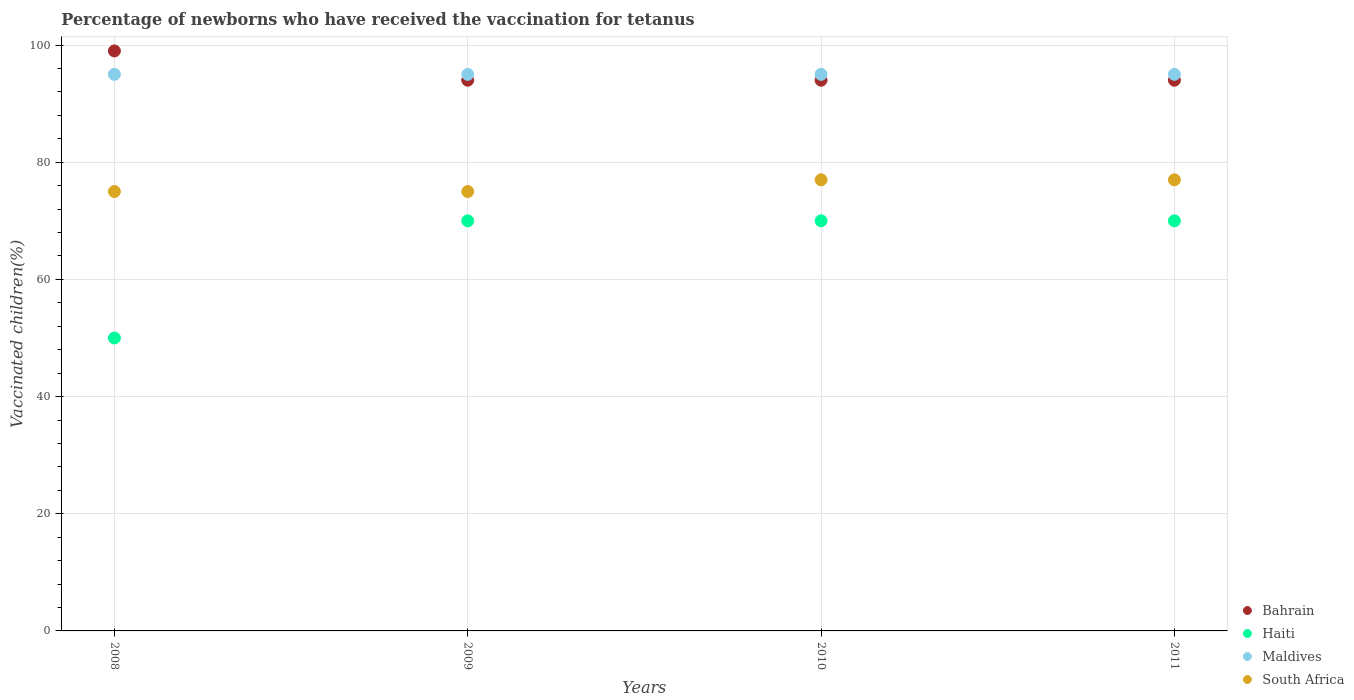How many different coloured dotlines are there?
Your answer should be compact. 4. What is the percentage of vaccinated children in Bahrain in 2008?
Offer a terse response. 99. Across all years, what is the maximum percentage of vaccinated children in Bahrain?
Give a very brief answer. 99. Across all years, what is the minimum percentage of vaccinated children in Bahrain?
Offer a very short reply. 94. In which year was the percentage of vaccinated children in Bahrain maximum?
Give a very brief answer. 2008. In which year was the percentage of vaccinated children in Maldives minimum?
Provide a succinct answer. 2008. What is the total percentage of vaccinated children in Haiti in the graph?
Provide a short and direct response. 260. What is the difference between the percentage of vaccinated children in Bahrain in 2008 and that in 2011?
Your response must be concise. 5. What is the difference between the percentage of vaccinated children in Haiti in 2010 and the percentage of vaccinated children in Maldives in 2009?
Keep it short and to the point. -25. What is the average percentage of vaccinated children in South Africa per year?
Provide a succinct answer. 76. In the year 2010, what is the difference between the percentage of vaccinated children in South Africa and percentage of vaccinated children in Maldives?
Ensure brevity in your answer.  -18. What is the ratio of the percentage of vaccinated children in Haiti in 2009 to that in 2011?
Offer a terse response. 1. Is the percentage of vaccinated children in Bahrain in 2008 less than that in 2011?
Your answer should be compact. No. What is the difference between the highest and the lowest percentage of vaccinated children in Maldives?
Your answer should be compact. 0. In how many years, is the percentage of vaccinated children in South Africa greater than the average percentage of vaccinated children in South Africa taken over all years?
Ensure brevity in your answer.  2. Is the percentage of vaccinated children in Maldives strictly less than the percentage of vaccinated children in Haiti over the years?
Your answer should be compact. No. How many dotlines are there?
Provide a short and direct response. 4. How many years are there in the graph?
Offer a very short reply. 4. Are the values on the major ticks of Y-axis written in scientific E-notation?
Keep it short and to the point. No. Does the graph contain any zero values?
Provide a succinct answer. No. How many legend labels are there?
Your answer should be compact. 4. How are the legend labels stacked?
Ensure brevity in your answer.  Vertical. What is the title of the graph?
Your response must be concise. Percentage of newborns who have received the vaccination for tetanus. What is the label or title of the X-axis?
Your answer should be compact. Years. What is the label or title of the Y-axis?
Your response must be concise. Vaccinated children(%). What is the Vaccinated children(%) in Bahrain in 2008?
Give a very brief answer. 99. What is the Vaccinated children(%) in South Africa in 2008?
Offer a very short reply. 75. What is the Vaccinated children(%) in Bahrain in 2009?
Provide a succinct answer. 94. What is the Vaccinated children(%) of Maldives in 2009?
Your answer should be very brief. 95. What is the Vaccinated children(%) in Bahrain in 2010?
Make the answer very short. 94. What is the Vaccinated children(%) in Haiti in 2010?
Provide a succinct answer. 70. What is the Vaccinated children(%) of South Africa in 2010?
Offer a terse response. 77. What is the Vaccinated children(%) in Bahrain in 2011?
Offer a very short reply. 94. What is the Vaccinated children(%) of Haiti in 2011?
Your answer should be compact. 70. What is the Vaccinated children(%) of Maldives in 2011?
Offer a very short reply. 95. Across all years, what is the maximum Vaccinated children(%) of Bahrain?
Offer a very short reply. 99. Across all years, what is the maximum Vaccinated children(%) of Haiti?
Ensure brevity in your answer.  70. Across all years, what is the maximum Vaccinated children(%) in Maldives?
Provide a succinct answer. 95. Across all years, what is the minimum Vaccinated children(%) in Bahrain?
Your answer should be compact. 94. Across all years, what is the minimum Vaccinated children(%) of Maldives?
Keep it short and to the point. 95. What is the total Vaccinated children(%) in Bahrain in the graph?
Your answer should be compact. 381. What is the total Vaccinated children(%) in Haiti in the graph?
Provide a short and direct response. 260. What is the total Vaccinated children(%) in Maldives in the graph?
Offer a very short reply. 380. What is the total Vaccinated children(%) in South Africa in the graph?
Offer a very short reply. 304. What is the difference between the Vaccinated children(%) in Bahrain in 2008 and that in 2009?
Provide a succinct answer. 5. What is the difference between the Vaccinated children(%) in Maldives in 2008 and that in 2009?
Offer a very short reply. 0. What is the difference between the Vaccinated children(%) in Haiti in 2008 and that in 2010?
Offer a terse response. -20. What is the difference between the Vaccinated children(%) of Maldives in 2008 and that in 2010?
Offer a terse response. 0. What is the difference between the Vaccinated children(%) in Bahrain in 2009 and that in 2010?
Provide a succinct answer. 0. What is the difference between the Vaccinated children(%) of South Africa in 2009 and that in 2010?
Provide a short and direct response. -2. What is the difference between the Vaccinated children(%) of Bahrain in 2009 and that in 2011?
Give a very brief answer. 0. What is the difference between the Vaccinated children(%) of Maldives in 2009 and that in 2011?
Offer a terse response. 0. What is the difference between the Vaccinated children(%) in South Africa in 2009 and that in 2011?
Your answer should be very brief. -2. What is the difference between the Vaccinated children(%) in Bahrain in 2010 and that in 2011?
Offer a very short reply. 0. What is the difference between the Vaccinated children(%) in South Africa in 2010 and that in 2011?
Your answer should be very brief. 0. What is the difference between the Vaccinated children(%) of Bahrain in 2008 and the Vaccinated children(%) of South Africa in 2009?
Offer a terse response. 24. What is the difference between the Vaccinated children(%) of Haiti in 2008 and the Vaccinated children(%) of Maldives in 2009?
Ensure brevity in your answer.  -45. What is the difference between the Vaccinated children(%) of Maldives in 2008 and the Vaccinated children(%) of South Africa in 2009?
Your answer should be compact. 20. What is the difference between the Vaccinated children(%) of Bahrain in 2008 and the Vaccinated children(%) of South Africa in 2010?
Provide a succinct answer. 22. What is the difference between the Vaccinated children(%) of Haiti in 2008 and the Vaccinated children(%) of Maldives in 2010?
Give a very brief answer. -45. What is the difference between the Vaccinated children(%) in Haiti in 2008 and the Vaccinated children(%) in South Africa in 2010?
Make the answer very short. -27. What is the difference between the Vaccinated children(%) of Maldives in 2008 and the Vaccinated children(%) of South Africa in 2010?
Ensure brevity in your answer.  18. What is the difference between the Vaccinated children(%) of Bahrain in 2008 and the Vaccinated children(%) of Haiti in 2011?
Your response must be concise. 29. What is the difference between the Vaccinated children(%) in Bahrain in 2008 and the Vaccinated children(%) in Maldives in 2011?
Offer a very short reply. 4. What is the difference between the Vaccinated children(%) in Haiti in 2008 and the Vaccinated children(%) in Maldives in 2011?
Your answer should be compact. -45. What is the difference between the Vaccinated children(%) of Haiti in 2008 and the Vaccinated children(%) of South Africa in 2011?
Offer a terse response. -27. What is the difference between the Vaccinated children(%) in Haiti in 2009 and the Vaccinated children(%) in Maldives in 2010?
Your response must be concise. -25. What is the difference between the Vaccinated children(%) in Haiti in 2009 and the Vaccinated children(%) in South Africa in 2010?
Make the answer very short. -7. What is the difference between the Vaccinated children(%) of Bahrain in 2009 and the Vaccinated children(%) of Haiti in 2011?
Your response must be concise. 24. What is the difference between the Vaccinated children(%) in Bahrain in 2009 and the Vaccinated children(%) in South Africa in 2011?
Make the answer very short. 17. What is the difference between the Vaccinated children(%) of Haiti in 2009 and the Vaccinated children(%) of Maldives in 2011?
Keep it short and to the point. -25. What is the difference between the Vaccinated children(%) in Bahrain in 2010 and the Vaccinated children(%) in Haiti in 2011?
Your answer should be compact. 24. What is the difference between the Vaccinated children(%) in Bahrain in 2010 and the Vaccinated children(%) in Maldives in 2011?
Your answer should be compact. -1. What is the difference between the Vaccinated children(%) in Bahrain in 2010 and the Vaccinated children(%) in South Africa in 2011?
Offer a terse response. 17. What is the difference between the Vaccinated children(%) in Haiti in 2010 and the Vaccinated children(%) in Maldives in 2011?
Provide a succinct answer. -25. What is the difference between the Vaccinated children(%) in Haiti in 2010 and the Vaccinated children(%) in South Africa in 2011?
Provide a succinct answer. -7. What is the average Vaccinated children(%) in Bahrain per year?
Your response must be concise. 95.25. What is the average Vaccinated children(%) in Haiti per year?
Provide a short and direct response. 65. What is the average Vaccinated children(%) of Maldives per year?
Keep it short and to the point. 95. What is the average Vaccinated children(%) of South Africa per year?
Provide a succinct answer. 76. In the year 2008, what is the difference between the Vaccinated children(%) in Bahrain and Vaccinated children(%) in Haiti?
Make the answer very short. 49. In the year 2008, what is the difference between the Vaccinated children(%) in Bahrain and Vaccinated children(%) in Maldives?
Make the answer very short. 4. In the year 2008, what is the difference between the Vaccinated children(%) in Bahrain and Vaccinated children(%) in South Africa?
Offer a very short reply. 24. In the year 2008, what is the difference between the Vaccinated children(%) in Haiti and Vaccinated children(%) in Maldives?
Give a very brief answer. -45. In the year 2008, what is the difference between the Vaccinated children(%) in Maldives and Vaccinated children(%) in South Africa?
Keep it short and to the point. 20. In the year 2009, what is the difference between the Vaccinated children(%) of Bahrain and Vaccinated children(%) of Haiti?
Provide a succinct answer. 24. In the year 2009, what is the difference between the Vaccinated children(%) in Bahrain and Vaccinated children(%) in Maldives?
Your answer should be compact. -1. In the year 2009, what is the difference between the Vaccinated children(%) of Bahrain and Vaccinated children(%) of South Africa?
Ensure brevity in your answer.  19. In the year 2009, what is the difference between the Vaccinated children(%) in Haiti and Vaccinated children(%) in South Africa?
Your response must be concise. -5. In the year 2010, what is the difference between the Vaccinated children(%) in Bahrain and Vaccinated children(%) in South Africa?
Provide a short and direct response. 17. In the year 2010, what is the difference between the Vaccinated children(%) of Haiti and Vaccinated children(%) of South Africa?
Make the answer very short. -7. In the year 2011, what is the difference between the Vaccinated children(%) in Maldives and Vaccinated children(%) in South Africa?
Keep it short and to the point. 18. What is the ratio of the Vaccinated children(%) in Bahrain in 2008 to that in 2009?
Give a very brief answer. 1.05. What is the ratio of the Vaccinated children(%) in Haiti in 2008 to that in 2009?
Your answer should be compact. 0.71. What is the ratio of the Vaccinated children(%) in Maldives in 2008 to that in 2009?
Give a very brief answer. 1. What is the ratio of the Vaccinated children(%) in Bahrain in 2008 to that in 2010?
Make the answer very short. 1.05. What is the ratio of the Vaccinated children(%) in Bahrain in 2008 to that in 2011?
Provide a succinct answer. 1.05. What is the ratio of the Vaccinated children(%) in Maldives in 2008 to that in 2011?
Your answer should be compact. 1. What is the ratio of the Vaccinated children(%) of Bahrain in 2009 to that in 2010?
Your answer should be compact. 1. What is the ratio of the Vaccinated children(%) in South Africa in 2009 to that in 2010?
Your answer should be compact. 0.97. What is the ratio of the Vaccinated children(%) of Bahrain in 2009 to that in 2011?
Ensure brevity in your answer.  1. What is the ratio of the Vaccinated children(%) of Maldives in 2009 to that in 2011?
Your answer should be compact. 1. What is the ratio of the Vaccinated children(%) of South Africa in 2009 to that in 2011?
Provide a short and direct response. 0.97. What is the ratio of the Vaccinated children(%) in Bahrain in 2010 to that in 2011?
Ensure brevity in your answer.  1. What is the ratio of the Vaccinated children(%) in South Africa in 2010 to that in 2011?
Make the answer very short. 1. What is the difference between the highest and the second highest Vaccinated children(%) in Bahrain?
Keep it short and to the point. 5. What is the difference between the highest and the second highest Vaccinated children(%) in Haiti?
Your answer should be compact. 0. What is the difference between the highest and the lowest Vaccinated children(%) in Bahrain?
Ensure brevity in your answer.  5. What is the difference between the highest and the lowest Vaccinated children(%) of Haiti?
Give a very brief answer. 20. What is the difference between the highest and the lowest Vaccinated children(%) of Maldives?
Offer a very short reply. 0. What is the difference between the highest and the lowest Vaccinated children(%) of South Africa?
Make the answer very short. 2. 